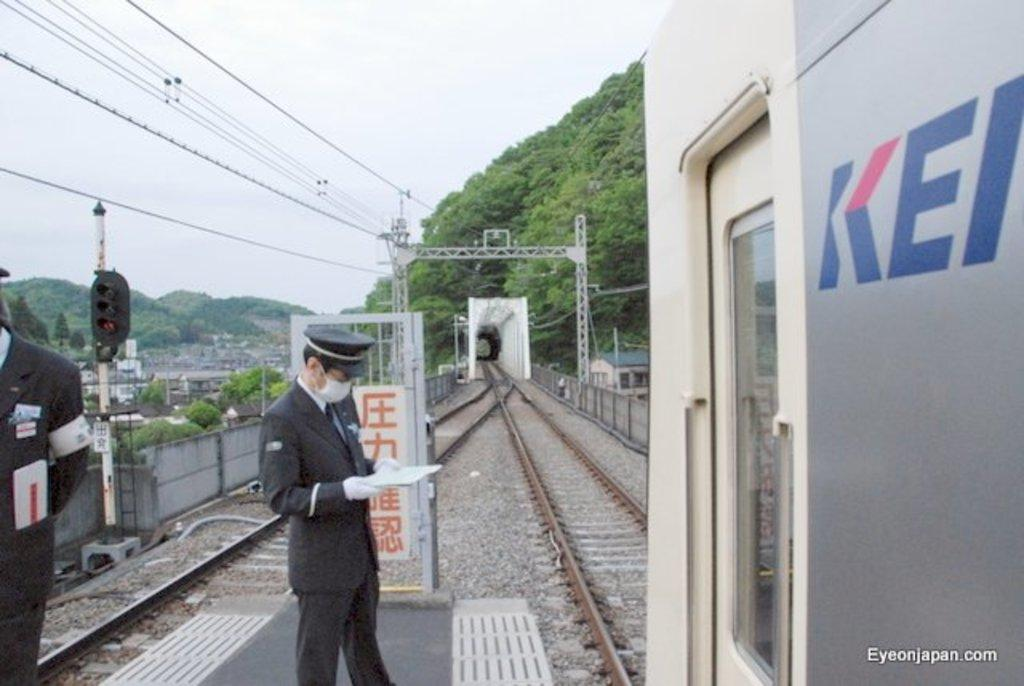What can be seen running along the ground in the image? There are train tracks in the image. What is on the tracks in the image? There is a train on the tracks. Who is present near the train tracks in the image? There are two people standing near the tracks. What type of natural feature can be seen in the image? There are mountains visible in the image. What type of man-made structures can be seen in the image? There are buildings in the image. What type of vertical structures can be seen in the image? There are poles in the image. What type of root can be seen growing near the train tracks in the image? There is no root visible in the image; it only features train tracks, a train, two people, mountains, buildings, and poles. What type of brass instrument is being played by the people near the train tracks in the image? There is no brass instrument or any musical instrument visible in the image. 